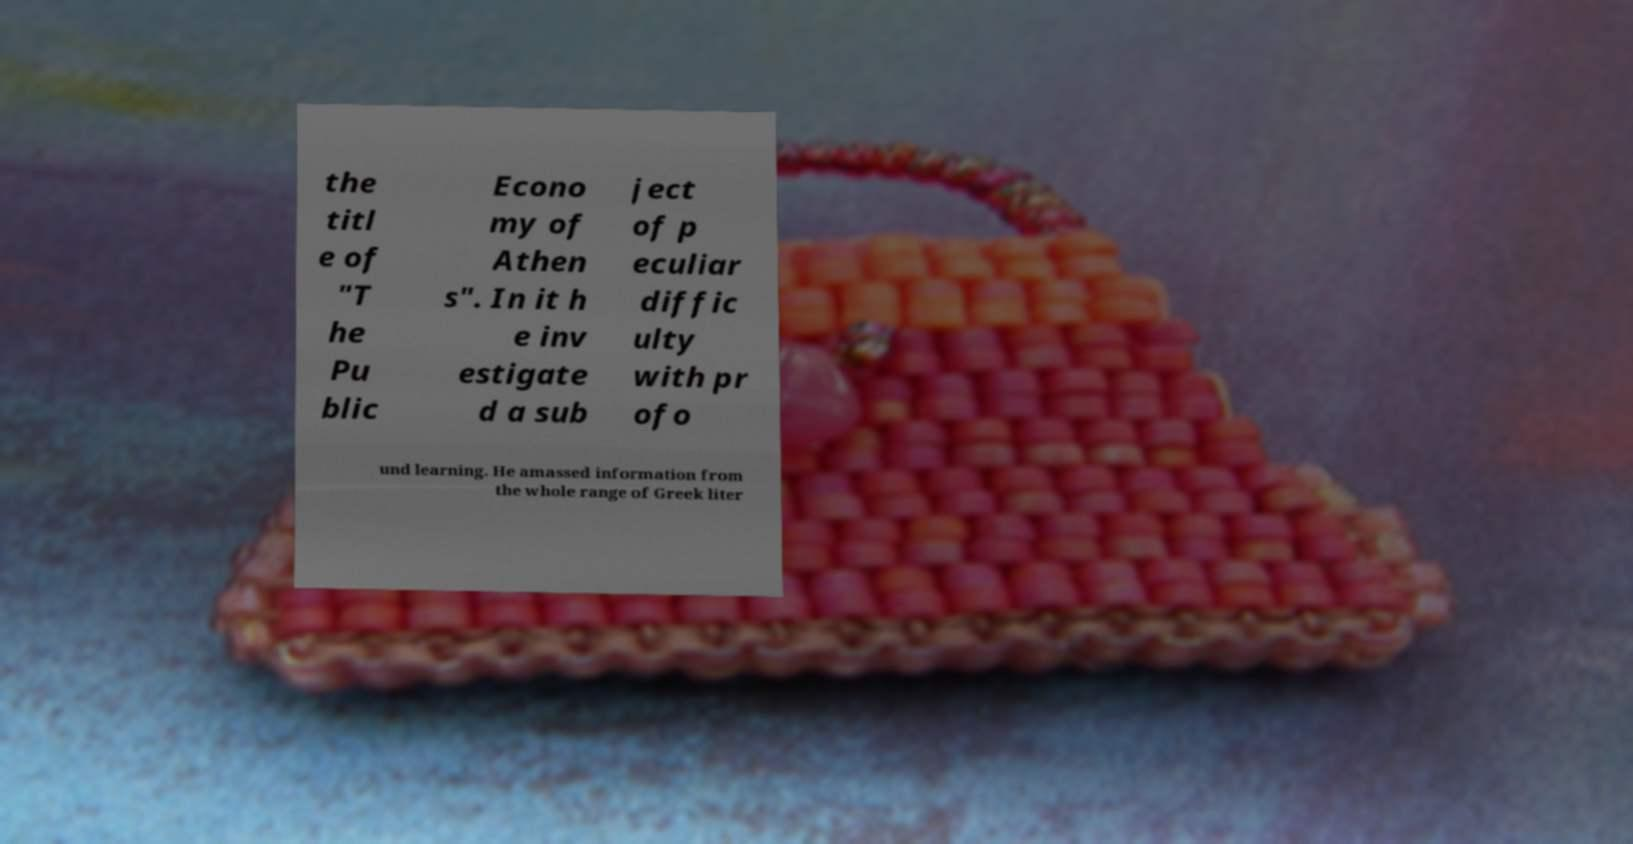For documentation purposes, I need the text within this image transcribed. Could you provide that? the titl e of "T he Pu blic Econo my of Athen s". In it h e inv estigate d a sub ject of p eculiar diffic ulty with pr ofo und learning. He amassed information from the whole range of Greek liter 